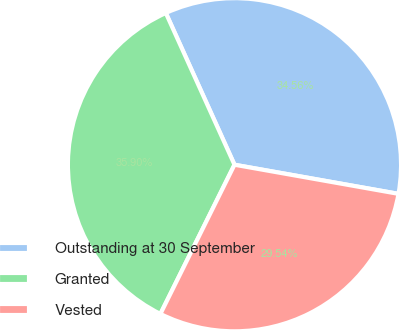Convert chart to OTSL. <chart><loc_0><loc_0><loc_500><loc_500><pie_chart><fcel>Outstanding at 30 September<fcel>Granted<fcel>Vested<nl><fcel>34.56%<fcel>35.9%<fcel>29.54%<nl></chart> 